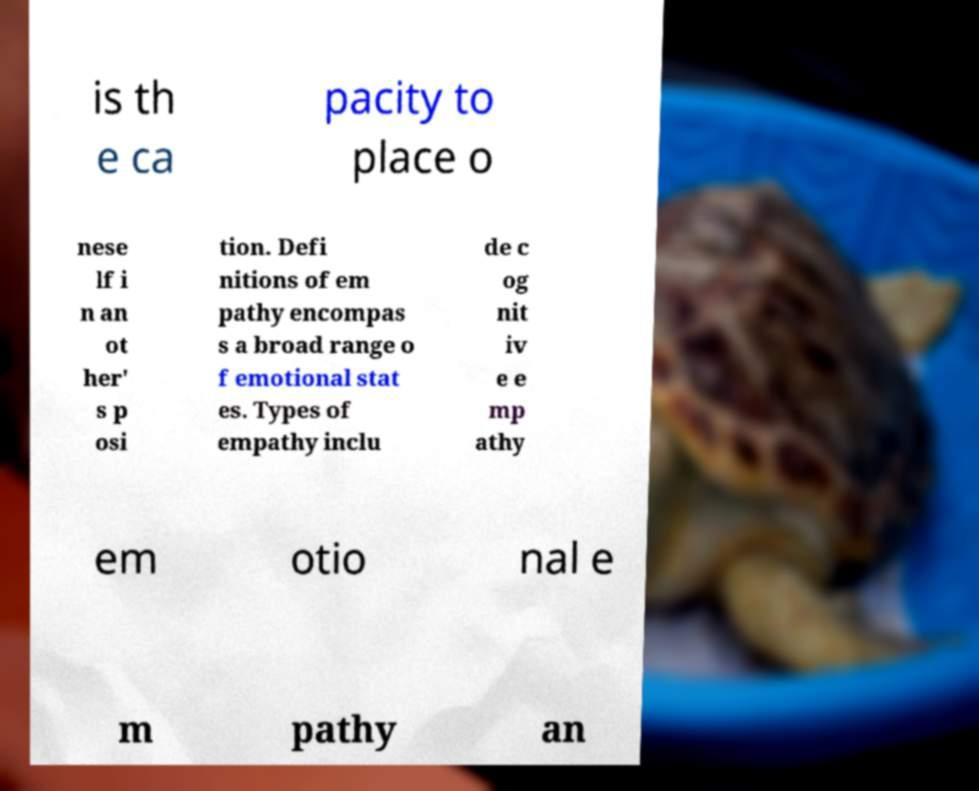Please read and relay the text visible in this image. What does it say? is th e ca pacity to place o nese lf i n an ot her' s p osi tion. Defi nitions of em pathy encompas s a broad range o f emotional stat es. Types of empathy inclu de c og nit iv e e mp athy em otio nal e m pathy an 